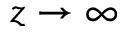Convert formula to latex. <formula><loc_0><loc_0><loc_500><loc_500>z \rightarrow \infty</formula> 